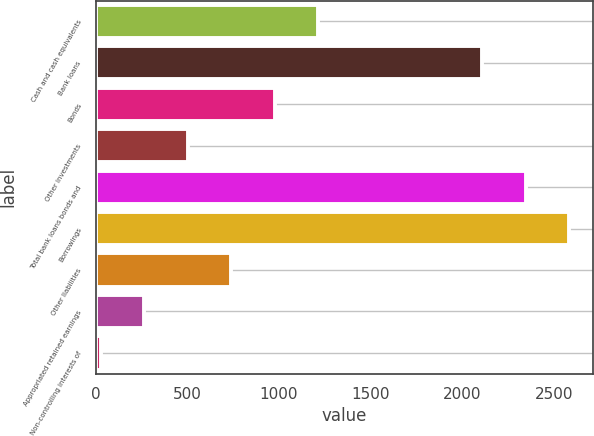<chart> <loc_0><loc_0><loc_500><loc_500><bar_chart><fcel>Cash and cash equivalents<fcel>Bank loans<fcel>Bonds<fcel>Other investments<fcel>Total bank loans bonds and<fcel>Borrowings<fcel>Other liabilities<fcel>Appropriated retained earnings<fcel>Non-controlling interests of<nl><fcel>1214.5<fcel>2110<fcel>977<fcel>502<fcel>2347.5<fcel>2585<fcel>739.5<fcel>264.5<fcel>27<nl></chart> 